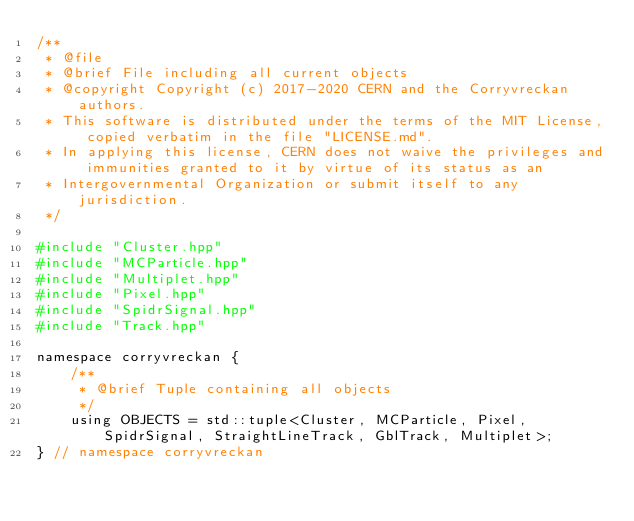<code> <loc_0><loc_0><loc_500><loc_500><_C_>/**
 * @file
 * @brief File including all current objects
 * @copyright Copyright (c) 2017-2020 CERN and the Corryvreckan authors.
 * This software is distributed under the terms of the MIT License, copied verbatim in the file "LICENSE.md".
 * In applying this license, CERN does not waive the privileges and immunities granted to it by virtue of its status as an
 * Intergovernmental Organization or submit itself to any jurisdiction.
 */

#include "Cluster.hpp"
#include "MCParticle.hpp"
#include "Multiplet.hpp"
#include "Pixel.hpp"
#include "SpidrSignal.hpp"
#include "Track.hpp"

namespace corryvreckan {
    /**
     * @brief Tuple containing all objects
     */
    using OBJECTS = std::tuple<Cluster, MCParticle, Pixel, SpidrSignal, StraightLineTrack, GblTrack, Multiplet>;
} // namespace corryvreckan
</code> 